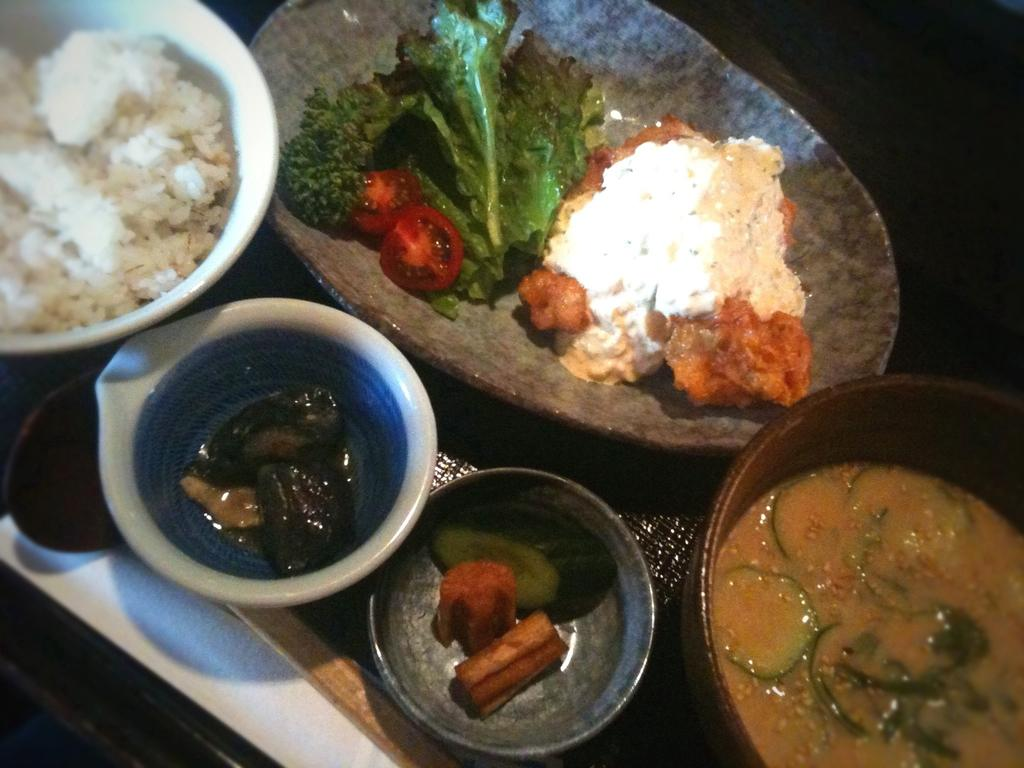What is the main object in the image? There is a tray in the image. What type of food is on the tray? There are bowls of curry on the tray, as well as a bowl with rice and a bowl with rice, leafy vegetables, and tomato slices. What type of muscle is visible in the image? There is no muscle visible in the image; it features a tray with bowls of curry and rice. 